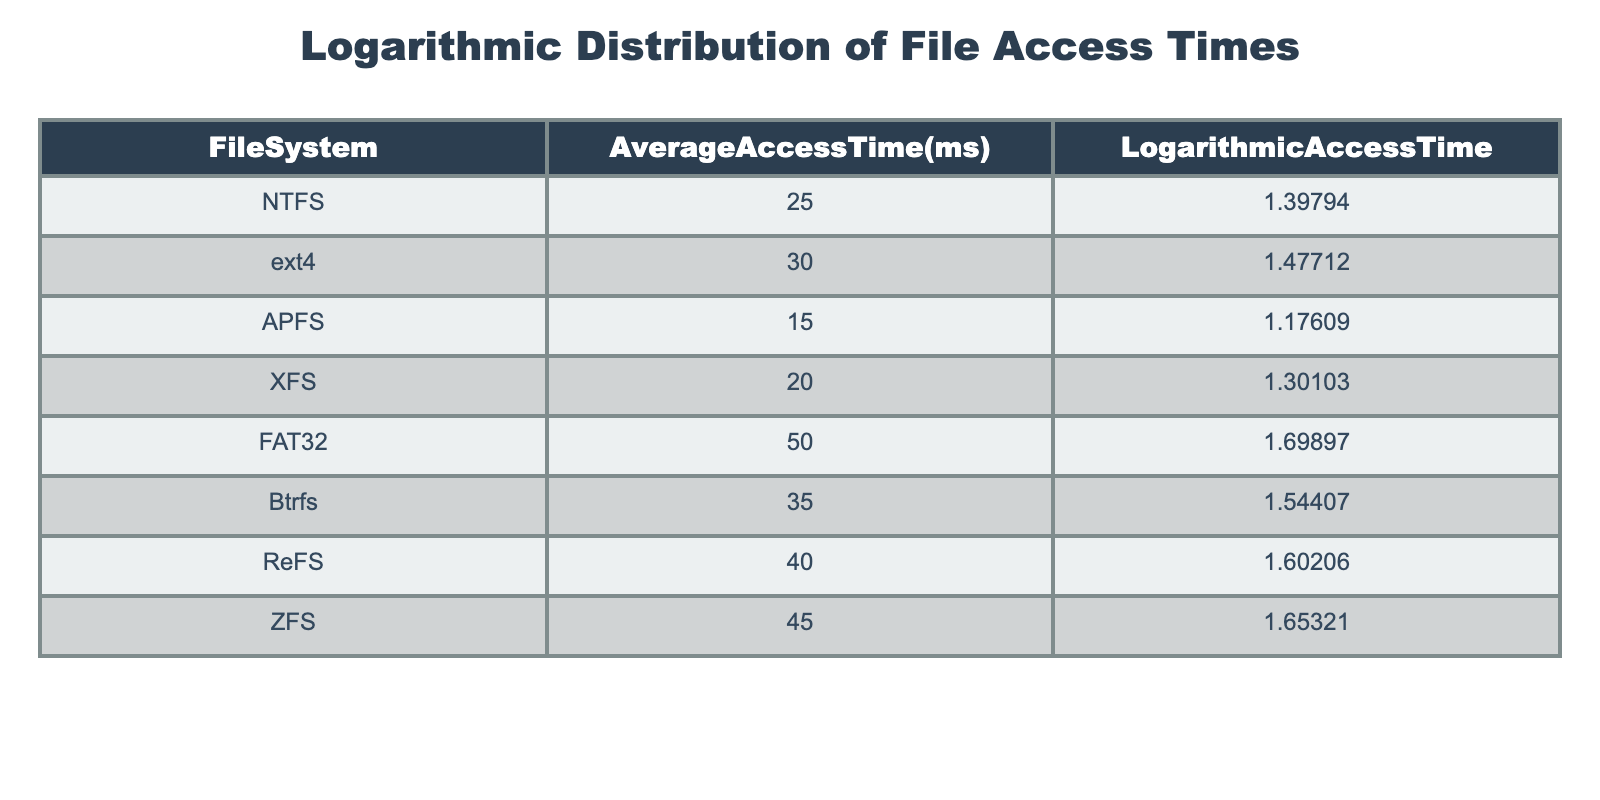What is the average access time for the ZFS file system? The table shows the average access time for ZFS is listed directly under the 'AverageAccessTime(ms)' column, which reads as 45 ms.
Answer: 45 ms Which file system has the lowest logarithmic access time? By looking at the 'LogarithmicAccessTime' column in the table, the smallest value is 1.17609, corresponding to the APFS file system.
Answer: APFS What is the difference in average access time between FAT32 and NTFS file systems? The average access time for FAT32 is 50 ms, while for NTFS it is 25 ms. The difference is 50 - 25 = 25 ms.
Answer: 25 ms Is the logarithmic access time for ext4 greater than that for XFS? The logarithmic access time for ext4 is 1.47712 and for XFS it is 1.30103. Since 1.47712 is greater than 1.30103, the answer is yes.
Answer: Yes What is the average of the average access times for all file systems? To find the average, we sum the average access times: 25 + 30 + 15 + 20 + 50 + 35 + 40 + 45 = 315. As there are 8 file systems, the average is 315 / 8 = 39.375 ms.
Answer: 39.375 ms What is the logarithmic access time for the file system with the highest average access time? Checking the 'AverageAccessTime(ms)' column, the highest value is 50 ms for the FAT32 file system. Looking at the corresponding 'LogarithmicAccessTime', it is 1.69897.
Answer: 1.69897 Are the average access times for Btrfs and ReFS the same? Btrfs has an average access time of 35 ms, while ReFS has 40 ms. These values are not equal, thus they are not the same.
Answer: No Which file system has an average access time that is 5 ms higher than that of the APFS? The average access time for APFS is 15 ms. Adding 5 ms gives us 20 ms. Referring to the table, XFS has 20 ms, making it the file system we're looking for.
Answer: XFS 